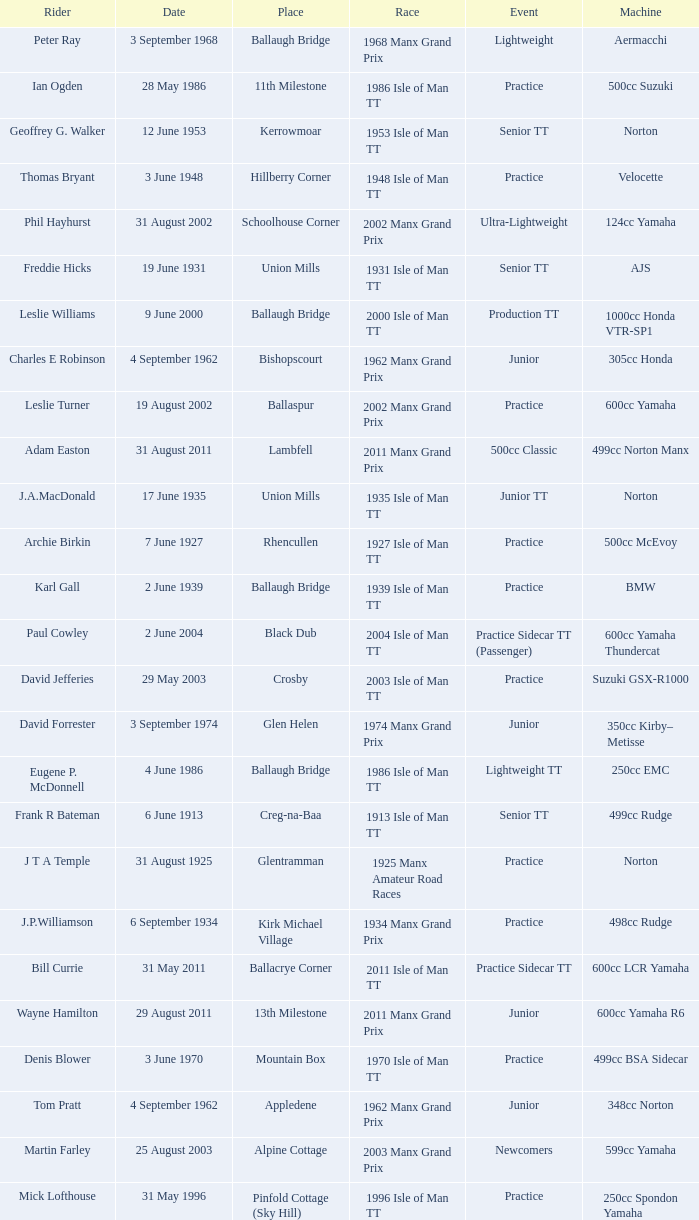What event was Rob Vine riding? Senior TT. 